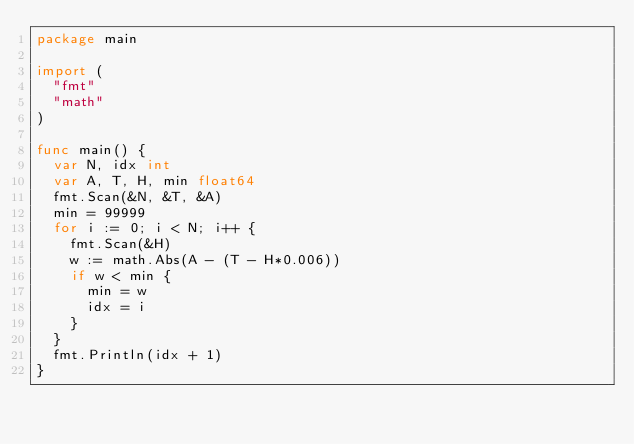<code> <loc_0><loc_0><loc_500><loc_500><_Go_>package main

import (
	"fmt"
	"math"
)

func main() {
	var N, idx int
	var A, T, H, min float64
	fmt.Scan(&N, &T, &A)
	min = 99999
	for i := 0; i < N; i++ {
		fmt.Scan(&H)
		w := math.Abs(A - (T - H*0.006))
		if w < min {
			min = w
			idx = i
		}
	}
	fmt.Println(idx + 1)
}</code> 